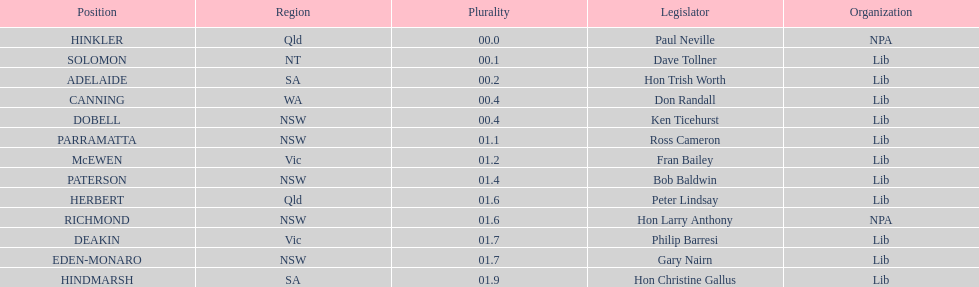What is the name of the last seat? HINDMARSH. 